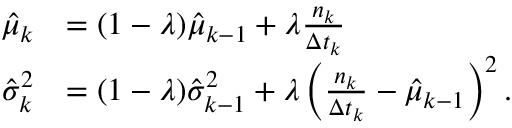Convert formula to latex. <formula><loc_0><loc_0><loc_500><loc_500>\begin{array} { r l } { \hat { \mu } _ { k } } & { = ( 1 - \lambda ) \hat { \mu } _ { k - 1 } + \lambda \frac { n _ { k } } { \Delta t _ { k } } } \\ { \hat { \sigma } _ { k } ^ { 2 } } & { = ( 1 - \lambda ) \hat { \sigma } _ { k - 1 } ^ { 2 } + \lambda \left ( \frac { n _ { k } } { \Delta t _ { k } } - \hat { \mu } _ { k - 1 } \right ) ^ { 2 } . } \end{array}</formula> 